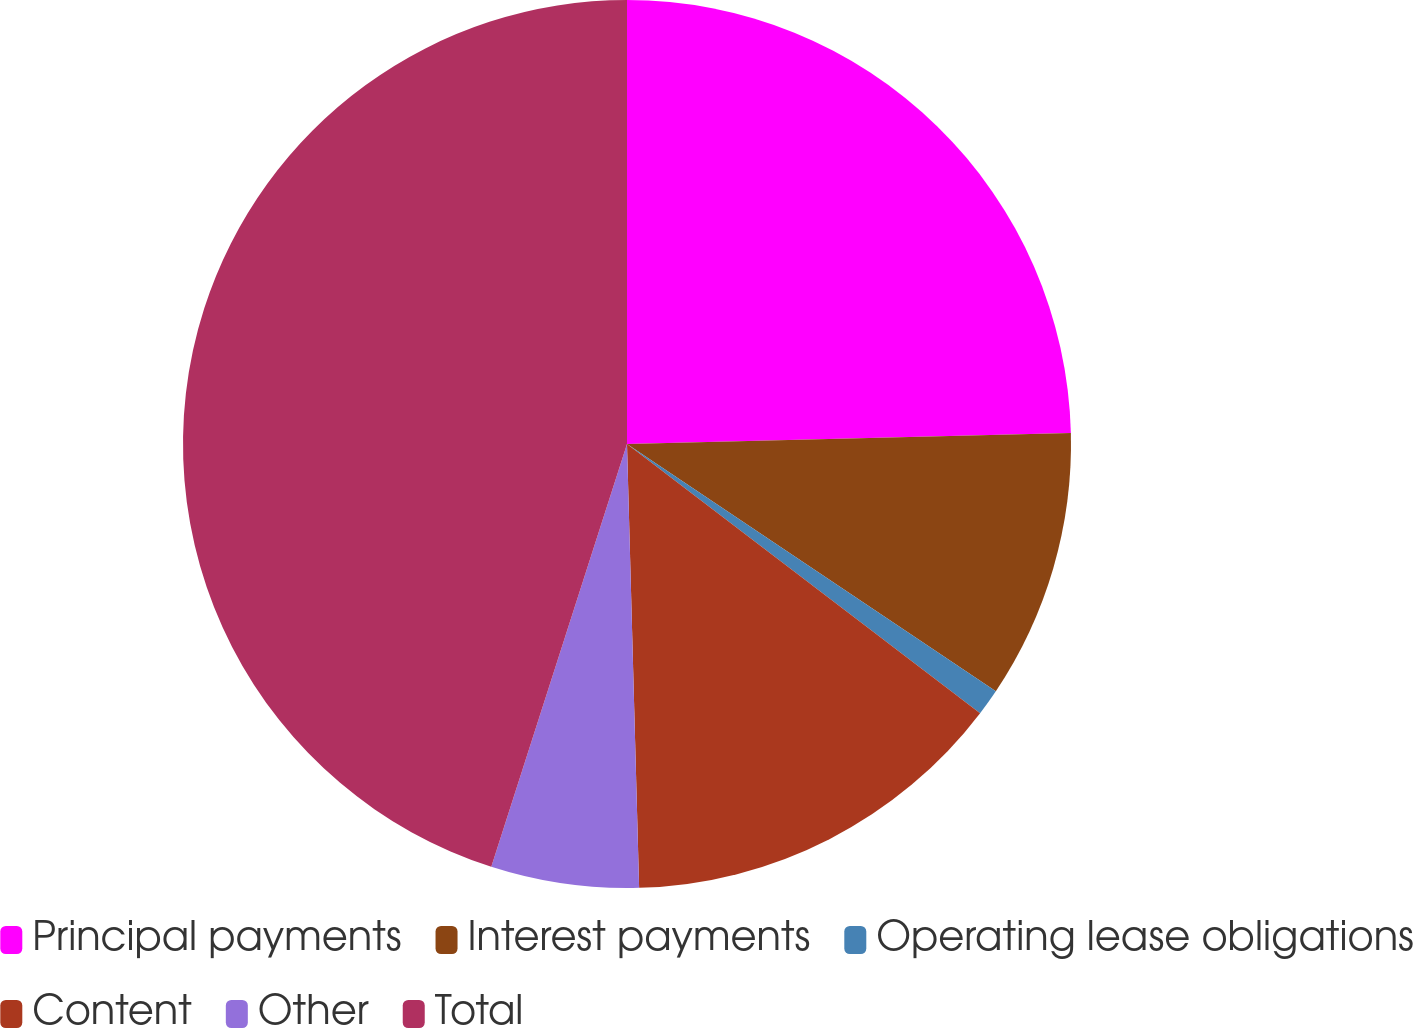Convert chart. <chart><loc_0><loc_0><loc_500><loc_500><pie_chart><fcel>Principal payments<fcel>Interest payments<fcel>Operating lease obligations<fcel>Content<fcel>Other<fcel>Total<nl><fcel>24.61%<fcel>9.79%<fcel>0.97%<fcel>14.2%<fcel>5.38%<fcel>45.06%<nl></chart> 